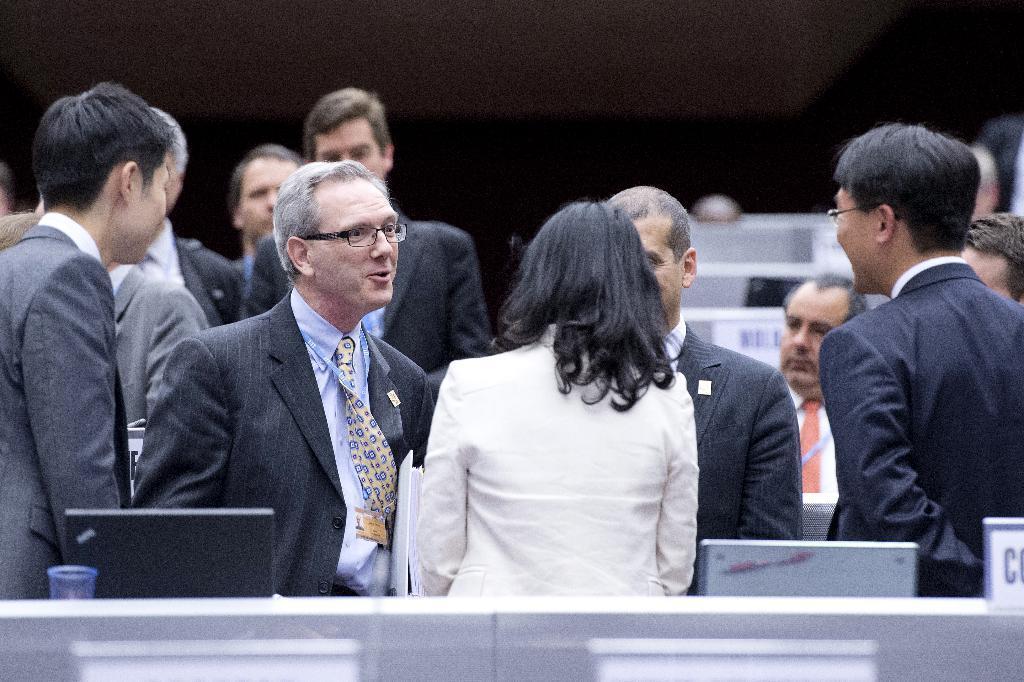Please provide a concise description of this image. In this image we can see persons standing on the floor. At the bottom of the image we can see laptops on the desk. In the background we can see desks and wall. 